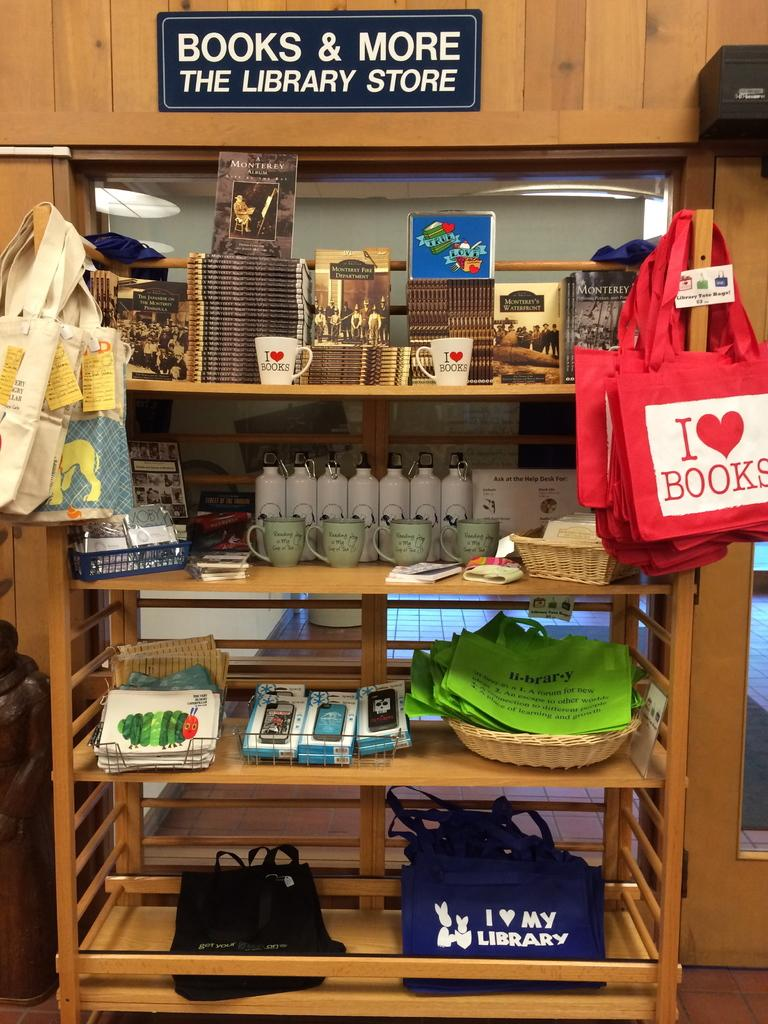What type of containers can be seen in the image? There are cups, bottles, and bags visible in the image. Are there any storage items in the image? Yes, there are baskets and bags in the shelves in the image. What is the purpose of the board with text in the image? The purpose of the board with text is not clear from the image, but it may be used for displaying information or instructions. What type of doctor is present in the image? There is no doctor present in the image. How does the temper of the bags affect the contents in the image? The temper of the bags does not affect the contents in the image, as there is no indication of temperature in the image. 